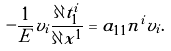Convert formula to latex. <formula><loc_0><loc_0><loc_500><loc_500>- \frac { 1 } { E } v _ { i } \frac { \partial t _ { 1 } ^ { i } } { \partial x ^ { 1 } } = a _ { 1 1 } n ^ { i } v _ { i } .</formula> 